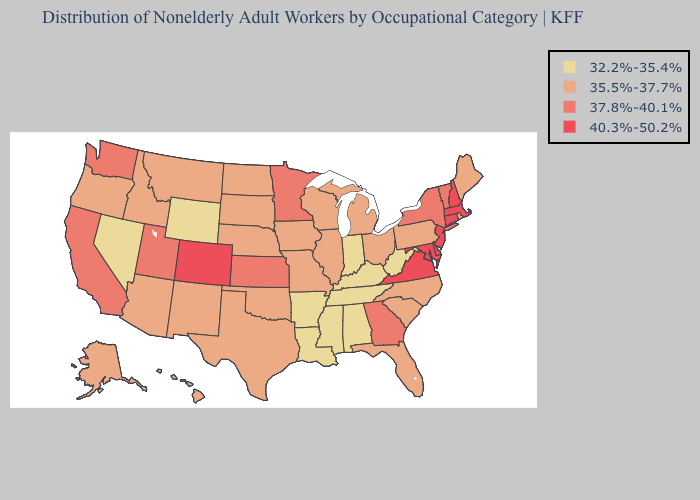Does New Mexico have a lower value than New Hampshire?
Short answer required. Yes. Which states have the lowest value in the MidWest?
Write a very short answer. Indiana. What is the value of Nebraska?
Give a very brief answer. 35.5%-37.7%. What is the lowest value in the USA?
Quick response, please. 32.2%-35.4%. Among the states that border Florida , does Georgia have the highest value?
Write a very short answer. Yes. Among the states that border Florida , does Georgia have the highest value?
Write a very short answer. Yes. Which states have the lowest value in the USA?
Be succinct. Alabama, Arkansas, Indiana, Kentucky, Louisiana, Mississippi, Nevada, Tennessee, West Virginia, Wyoming. What is the value of North Carolina?
Quick response, please. 35.5%-37.7%. How many symbols are there in the legend?
Write a very short answer. 4. Name the states that have a value in the range 37.8%-40.1%?
Answer briefly. California, Georgia, Kansas, Minnesota, New York, Utah, Vermont, Washington. What is the value of Colorado?
Be succinct. 40.3%-50.2%. What is the value of Washington?
Short answer required. 37.8%-40.1%. What is the highest value in the South ?
Concise answer only. 40.3%-50.2%. Among the states that border South Carolina , does Georgia have the lowest value?
Short answer required. No. Name the states that have a value in the range 32.2%-35.4%?
Write a very short answer. Alabama, Arkansas, Indiana, Kentucky, Louisiana, Mississippi, Nevada, Tennessee, West Virginia, Wyoming. 